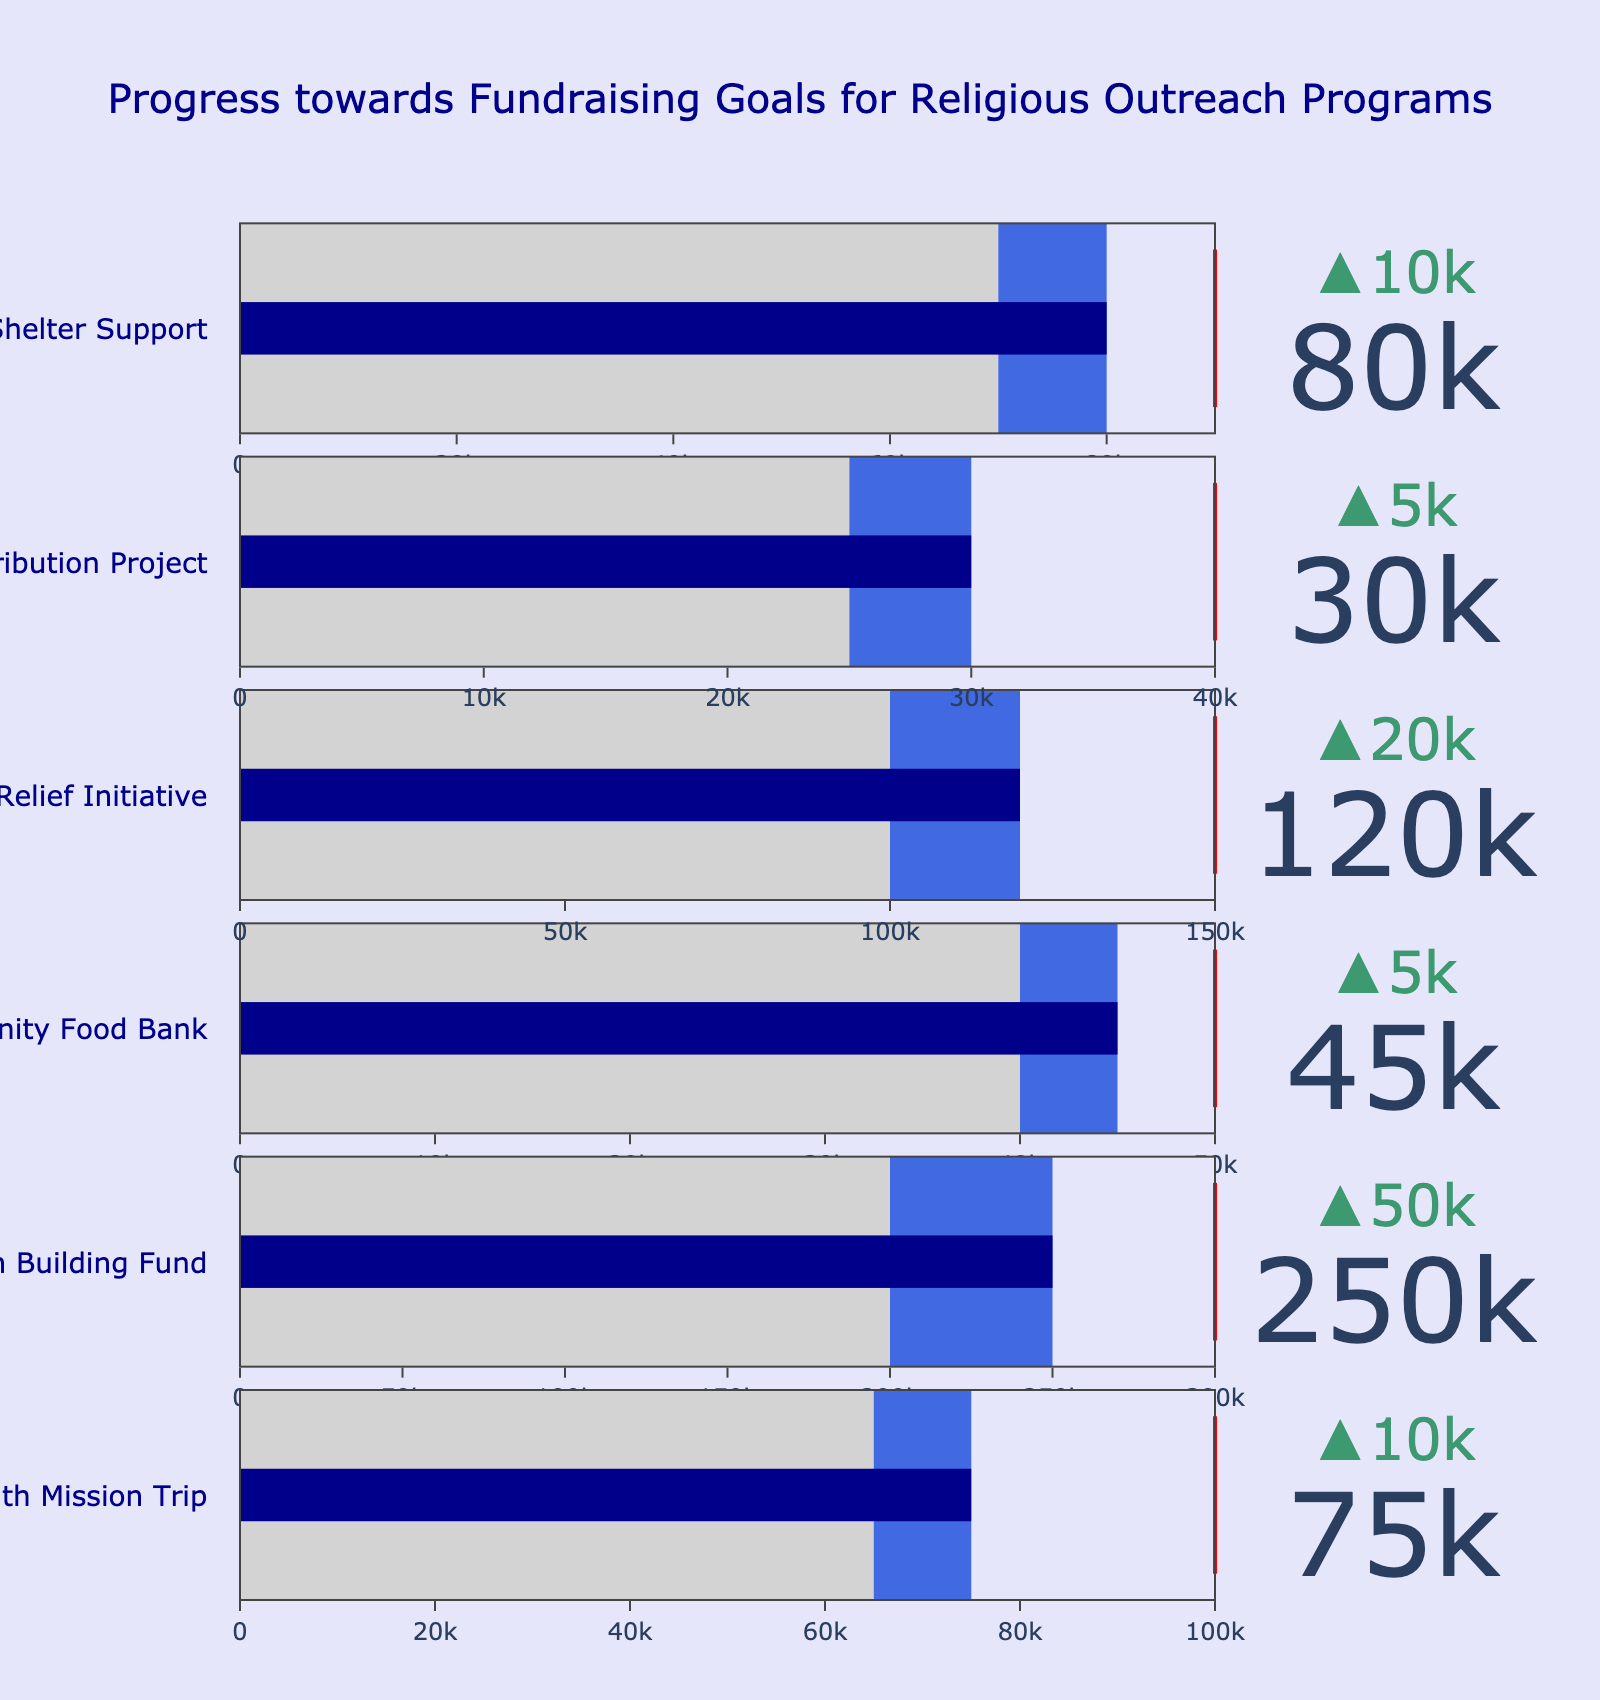What is the title of the figure? The title is prominently displayed at the top of the figure and reads: "Progress towards Fundraising Goals for Religious Outreach Programs".
Answer: Progress towards Fundraising Goals for Religious Outreach Programs How many programs are displayed in the figure? Count the number of bullet charts, each representing a different program. There are 6 bullet charts, hence 6 programs.
Answer: 6 Which program has the highest fundraising target? Look at the maximum value in the bullet charts' axes. The Church Building Fund has a target of $300,000, which is the highest.
Answer: Church Building Fund What is the actual amount raised for the Youth Mission Trip? Identify the actual value displayed within the bullet chart for the Youth Mission Trip. It shows $75,000.
Answer: $75,000 Which program has the closest actual amount to its target? Compare the actual amounts against targets by looking at the lengths of the blue bars within each bullet chart. The Church Building Fund has raised $250,000 against a target of $300,000 which is the closest proportionally.
Answer: Church Building Fund Which program exceeded its previous year's amount the most? Look at the delta values (the difference) that are shown with arrows on each bullet chart. The Youth Mission Trip increased from $65,000 to $75,000, showing the largest increase from the previous year.
Answer: Youth Mission Trip How much more does the Disaster Relief Initiative need to reach its target? Subtract the actual amount raised for Disaster Relief Initiative ($120,000) from its target amount ($150,000). So, $150,000 - $120,000 = $30,000.
Answer: $30,000 What is the combined actual amount raised for the Community Food Bank and the Homeless Shelter Support? Add the actual raised amounts of the Community Food Bank ($45,000) and the Homeless Shelter Support ($80,000). So, $45,000 + $80,000 = $125,000.
Answer: $125,000 Which program has raised the least funds compared to its target? Examine the ratios of actual amount to the target. The Bible Distribution Project has raised $30,000 against a target of $40,000, which is the lowest proportionally.
Answer: Bible Distribution Project 